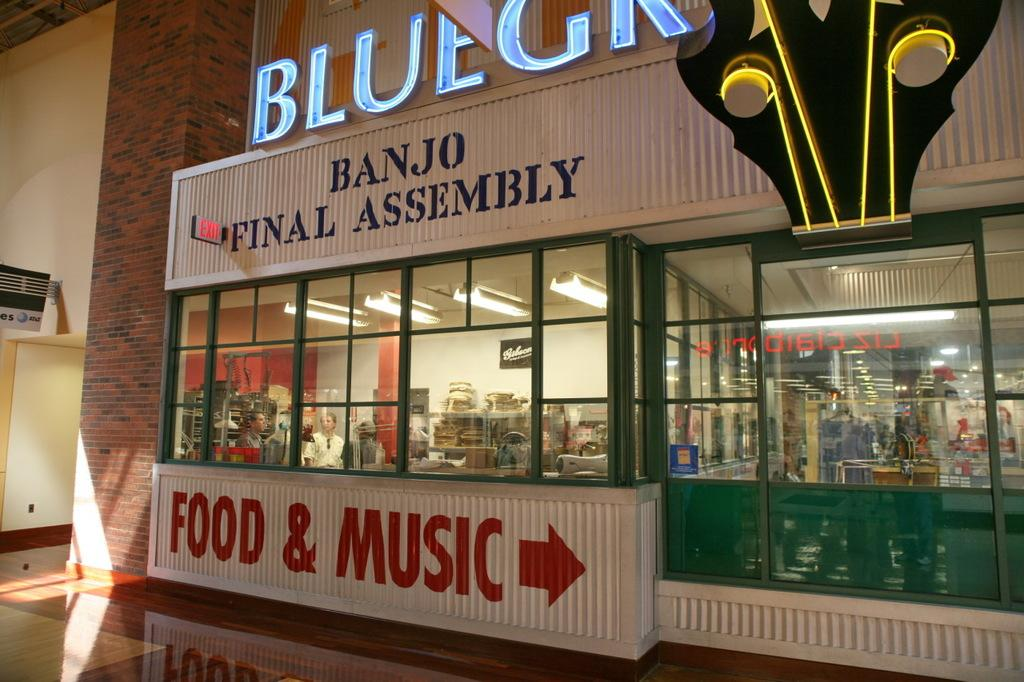What type of surface can be seen in the image? There is a floor in the image. What architectural feature is present in the image? There is a pillar in the image. What type of signage is visible in the image? There are name boards in the image. What type of illumination is present in the image? There are lights in the image. What type of material is present in the image? There is glass in the image. What type of furniture is present in the image? There is a table in the image. What type of decorative elements are visible in the image? There are posters in the image. What type of enclosure is present in the image? There are walls in the image. How many people are present in the image? There are two people in the image. What type of objects are present in the image? There are some objects in the image. What type of curve can be seen in the image? There is no curve present in the image. What type of room is depicted in the image? The image does not depict a room; it shows a space with walls, a floor, and other elements. What type of soap is visible in the image? There is no soap present in the image. 